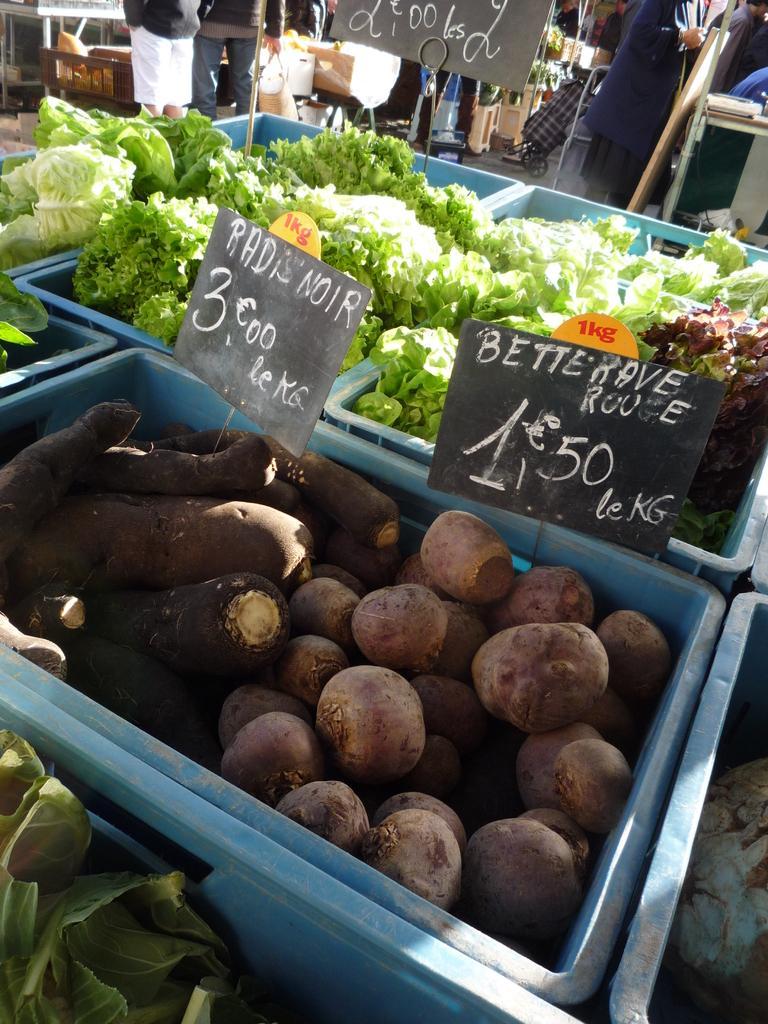How would you summarize this image in a sentence or two? In this picture there are different types of vegetables in the basket and there are boards in the basket and there is a text on the boards. At the back there are group of people standing at the tables. 